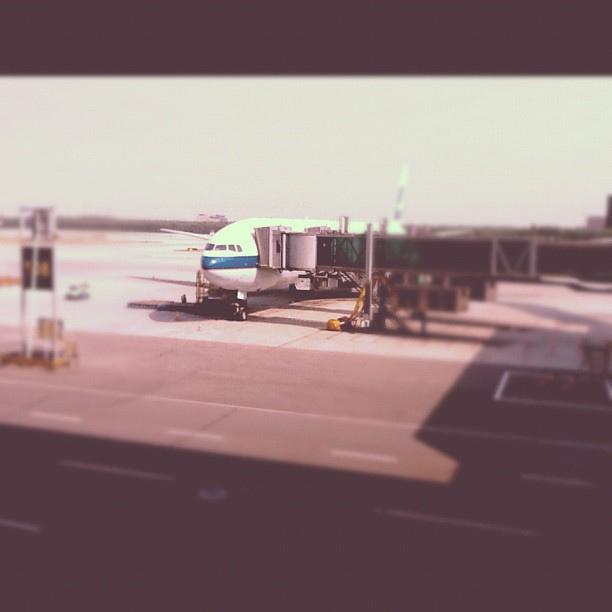What area of the airport is this?
Concise answer only. Runway. Are these real vehicles?
Quick response, please. Yes. Is this a one story building?
Write a very short answer. No. Is it cloudy?
Give a very brief answer. No. Is that airplane ready for takeoff?
Short answer required. No. Black and white?
Answer briefly. No. Where is the picture taken at?
Concise answer only. Airport. What do the lines on the pavement mean?
Short answer required. Lanes. What color is the stripe around the nose of the plane?
Concise answer only. Blue. Is there traffic on the road?
Quick response, please. No. 